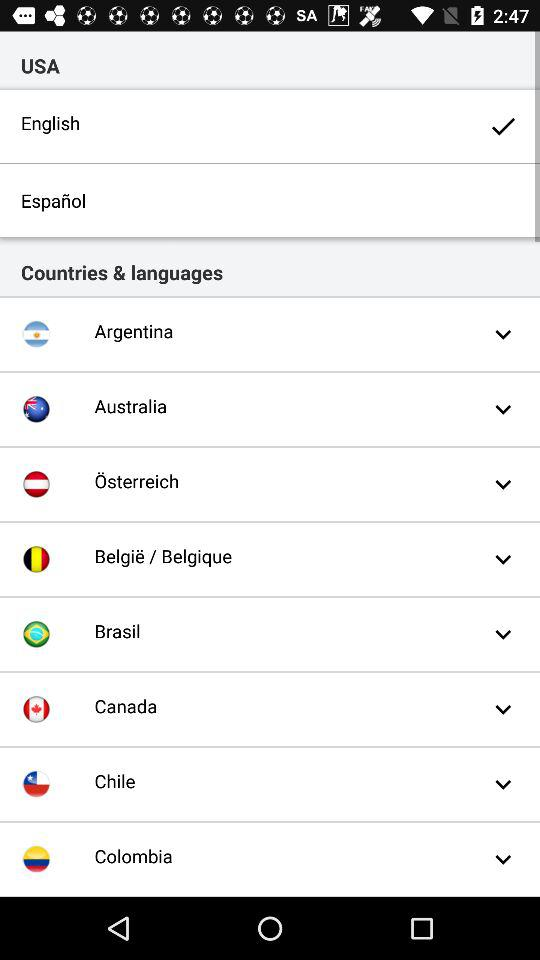Which option is selected? The selected option is "English". 